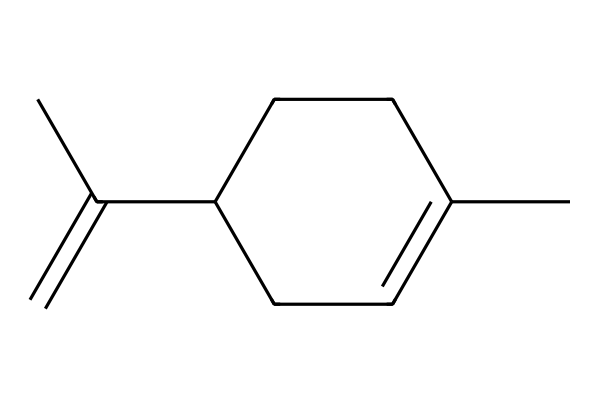What is the molecular formula of limonene based on its structure? To determine the molecular formula, we need to count the number of carbon (C) and hydrogen (H) atoms in the structure. From the visualization of the SMILES representation, we see there are 10 carbons and 16 hydrogens. Therefore, the molecular formula is C10H16.
Answer: C10H16 How many chiral centers are present in limonene? By examining the structure, we identify that a chiral center is typically a carbon atom bonded to four different substituents. In this case, there is one carbon atom that meets these criteria, indicating one chiral center present in limonene.
Answer: 1 What type of isomerism does limonene exhibit? Given that limonene has a chiral center, it can exist in two different forms (enantiomers) that are mirror images of each other, which is a hallmark of optical isomerism.
Answer: optical isomerism How many rings are present in limonene's structure? In the SMILES representation, we observe that a cyclic structure is indicated by the presence of digits (1 in this case), which indicates that there is one ring in limonene's structure.
Answer: 1 What is the main functional group present in limonene? The structure lacks any specific functional groups like hydroxyl or carbonyl groups but consists mainly of carbon chains and double bonds, characterizing it as a hydrocarbon. Since it’s primarily an alkene due to the presence of a double bond, we categorize its main functional group as an alkene.
Answer: alkene What is the significance of limonene in sports drinks? Limonene is commonly used in flavoring due to its citrus scent and taste, which is refreshing and enhances the overall palatability of beverages, making it significant in sports drinks for flavor enhancement.
Answer: flavoring 